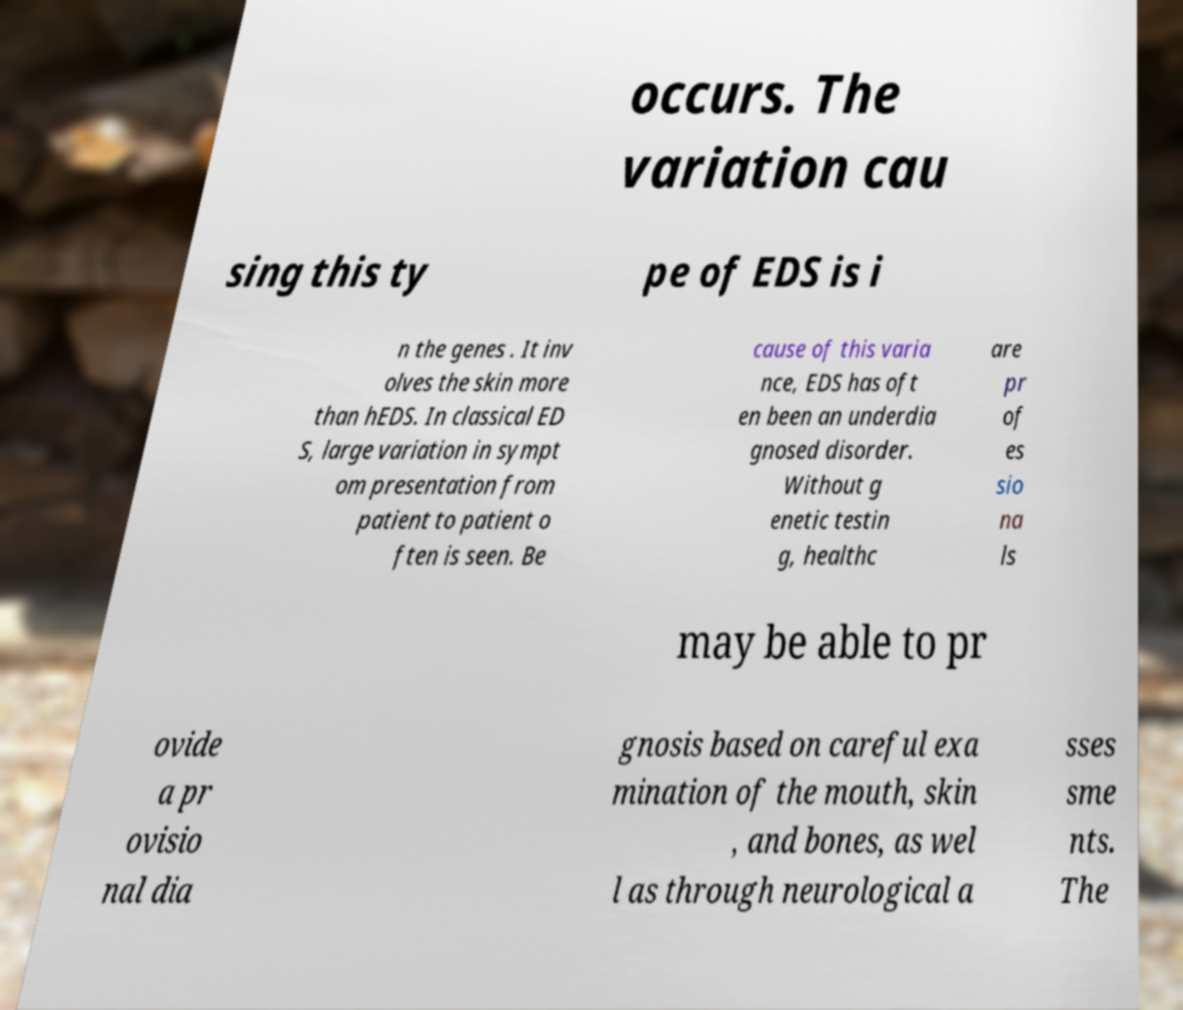Could you extract and type out the text from this image? occurs. The variation cau sing this ty pe of EDS is i n the genes . It inv olves the skin more than hEDS. In classical ED S, large variation in sympt om presentation from patient to patient o ften is seen. Be cause of this varia nce, EDS has oft en been an underdia gnosed disorder. Without g enetic testin g, healthc are pr of es sio na ls may be able to pr ovide a pr ovisio nal dia gnosis based on careful exa mination of the mouth, skin , and bones, as wel l as through neurological a sses sme nts. The 